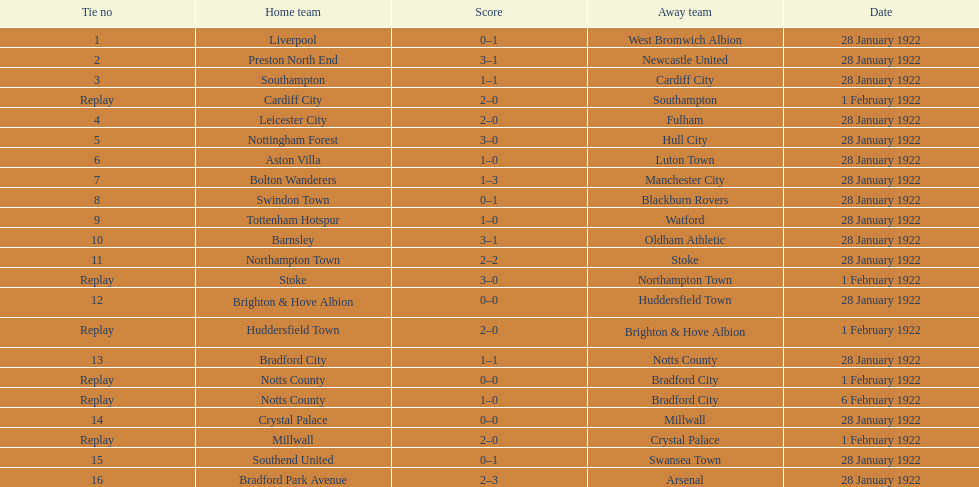How many games had no points scored? 3. 